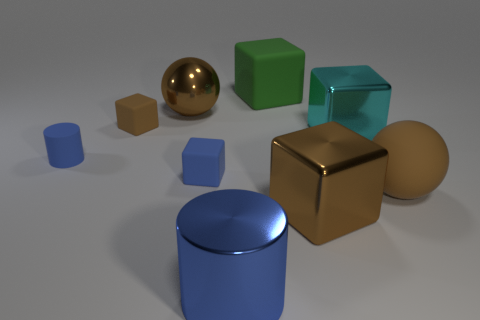Subtract all big blocks. How many blocks are left? 2 Subtract 1 blue blocks. How many objects are left? 8 Subtract all cylinders. How many objects are left? 7 Subtract all gray spheres. Subtract all yellow cylinders. How many spheres are left? 2 Subtract all blue cylinders. How many yellow cubes are left? 0 Subtract all small green metallic cylinders. Subtract all green rubber cubes. How many objects are left? 8 Add 5 big brown cubes. How many big brown cubes are left? 6 Add 2 brown balls. How many brown balls exist? 4 Add 1 rubber cubes. How many objects exist? 10 Subtract all blue cubes. How many cubes are left? 4 